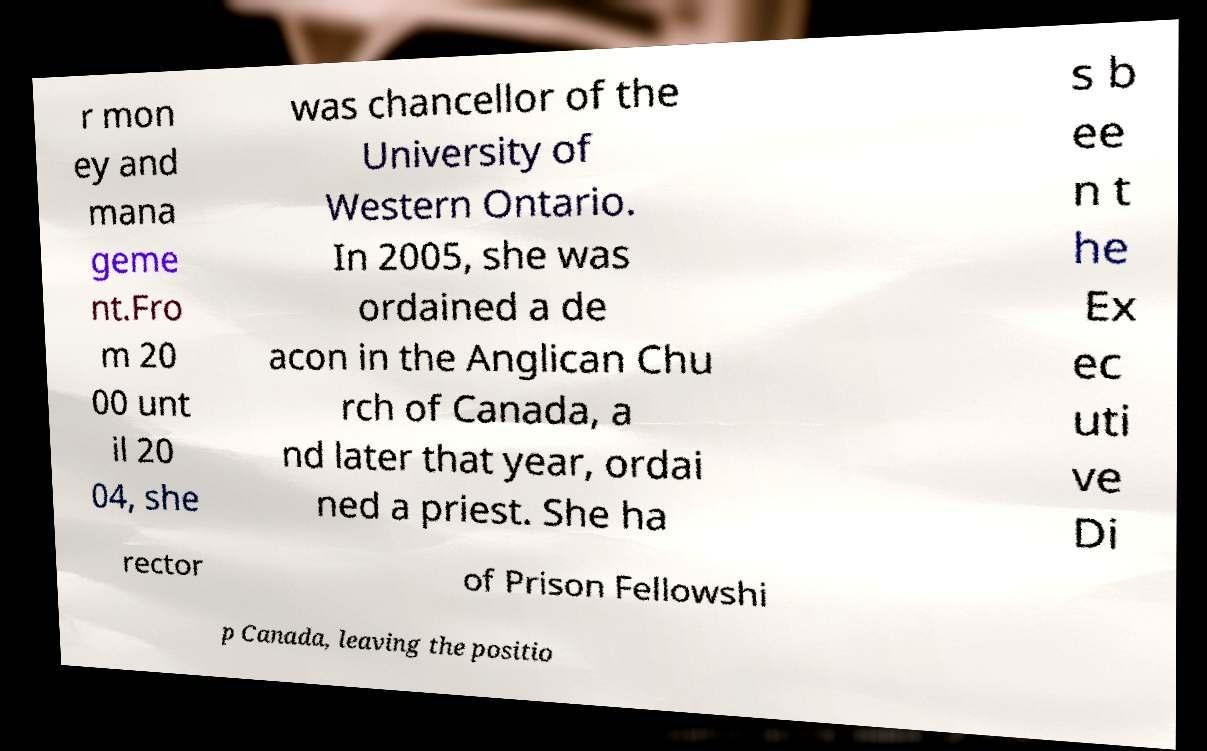For documentation purposes, I need the text within this image transcribed. Could you provide that? r mon ey and mana geme nt.Fro m 20 00 unt il 20 04, she was chancellor of the University of Western Ontario. In 2005, she was ordained a de acon in the Anglican Chu rch of Canada, a nd later that year, ordai ned a priest. She ha s b ee n t he Ex ec uti ve Di rector of Prison Fellowshi p Canada, leaving the positio 